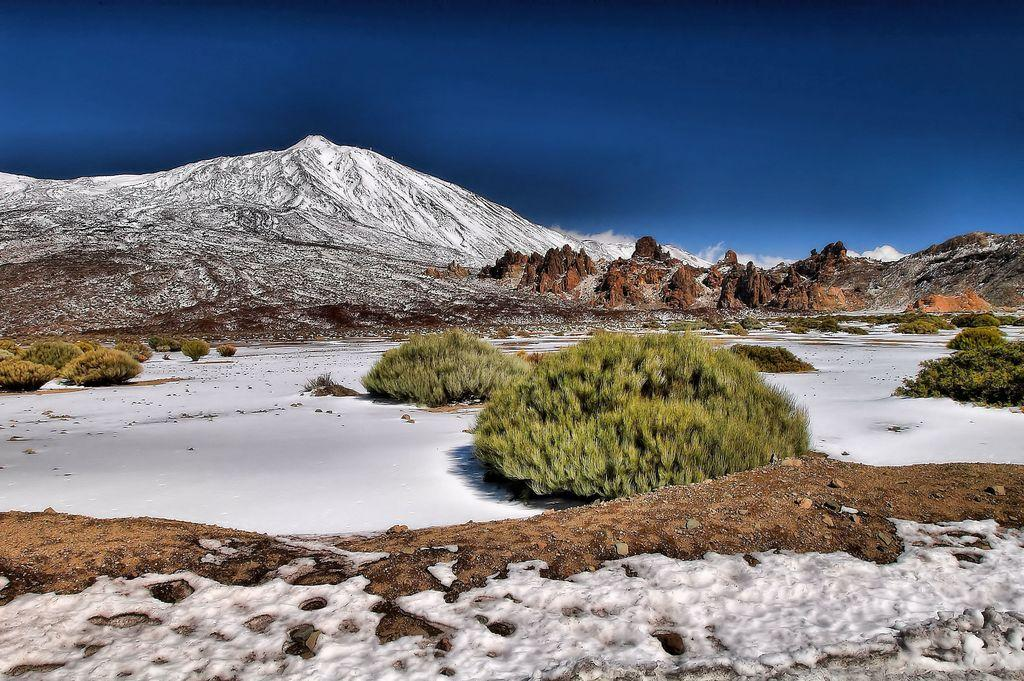What type of terrain is visible in the image? There are hills in the image. What color is the sky in the image? The sky is blue in the image. What type of vegetation can be seen in the image? There are plants in the image. What type of natural feature is present in the image? There are rocks in the image. What weather condition is depicted in the image? There is snow in the image. How many sheep are visible in the image? There are no sheep present in the image. What type of whip is being used to control the sheep in the image? There are no sheep or whips present in the image. 